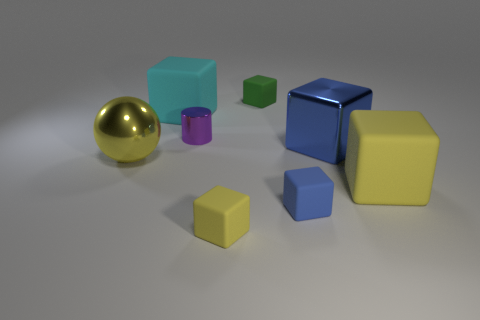How many large objects are either metal spheres or green matte things?
Your response must be concise. 1. Does the tiny yellow object have the same shape as the blue metal thing?
Keep it short and to the point. Yes. What number of yellow things are left of the purple shiny cylinder and in front of the big yellow ball?
Keep it short and to the point. 0. Is there any other thing of the same color as the tiny cylinder?
Your answer should be compact. No. The tiny blue object that is the same material as the tiny green object is what shape?
Keep it short and to the point. Cube. Does the purple cylinder have the same size as the metal block?
Your answer should be compact. No. Are the yellow object that is on the left side of the purple shiny cylinder and the large blue thing made of the same material?
Make the answer very short. Yes. Are there any other things that are the same material as the small yellow object?
Give a very brief answer. Yes. What number of tiny objects are on the left side of the matte thing that is behind the big cube that is behind the small shiny object?
Your answer should be compact. 2. There is a yellow matte thing right of the tiny blue cube; is it the same shape as the blue shiny object?
Keep it short and to the point. Yes. 